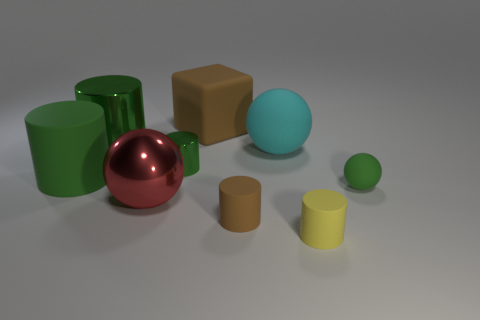How many green cylinders must be subtracted to get 1 green cylinders? 2 Subtract all gray balls. How many green cylinders are left? 3 Subtract 2 cylinders. How many cylinders are left? 3 Subtract all yellow cylinders. How many cylinders are left? 4 Subtract all brown cylinders. How many cylinders are left? 4 Subtract all gray balls. Subtract all purple cylinders. How many balls are left? 3 Subtract all cylinders. How many objects are left? 4 Add 1 big metallic things. How many big metallic things exist? 3 Subtract 0 brown balls. How many objects are left? 9 Subtract all big matte cubes. Subtract all green balls. How many objects are left? 7 